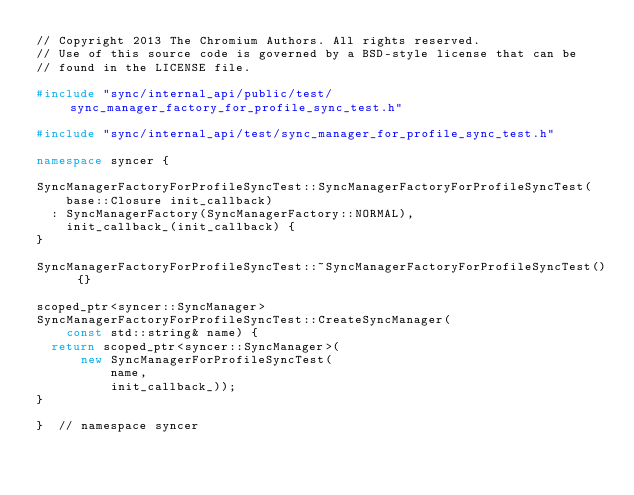Convert code to text. <code><loc_0><loc_0><loc_500><loc_500><_C++_>// Copyright 2013 The Chromium Authors. All rights reserved.
// Use of this source code is governed by a BSD-style license that can be
// found in the LICENSE file.

#include "sync/internal_api/public/test/sync_manager_factory_for_profile_sync_test.h"

#include "sync/internal_api/test/sync_manager_for_profile_sync_test.h"

namespace syncer {

SyncManagerFactoryForProfileSyncTest::SyncManagerFactoryForProfileSyncTest(
    base::Closure init_callback)
  : SyncManagerFactory(SyncManagerFactory::NORMAL),
    init_callback_(init_callback) {
}

SyncManagerFactoryForProfileSyncTest::~SyncManagerFactoryForProfileSyncTest() {}

scoped_ptr<syncer::SyncManager>
SyncManagerFactoryForProfileSyncTest::CreateSyncManager(
    const std::string& name) {
  return scoped_ptr<syncer::SyncManager>(
      new SyncManagerForProfileSyncTest(
          name,
          init_callback_));
}

}  // namespace syncer
</code> 